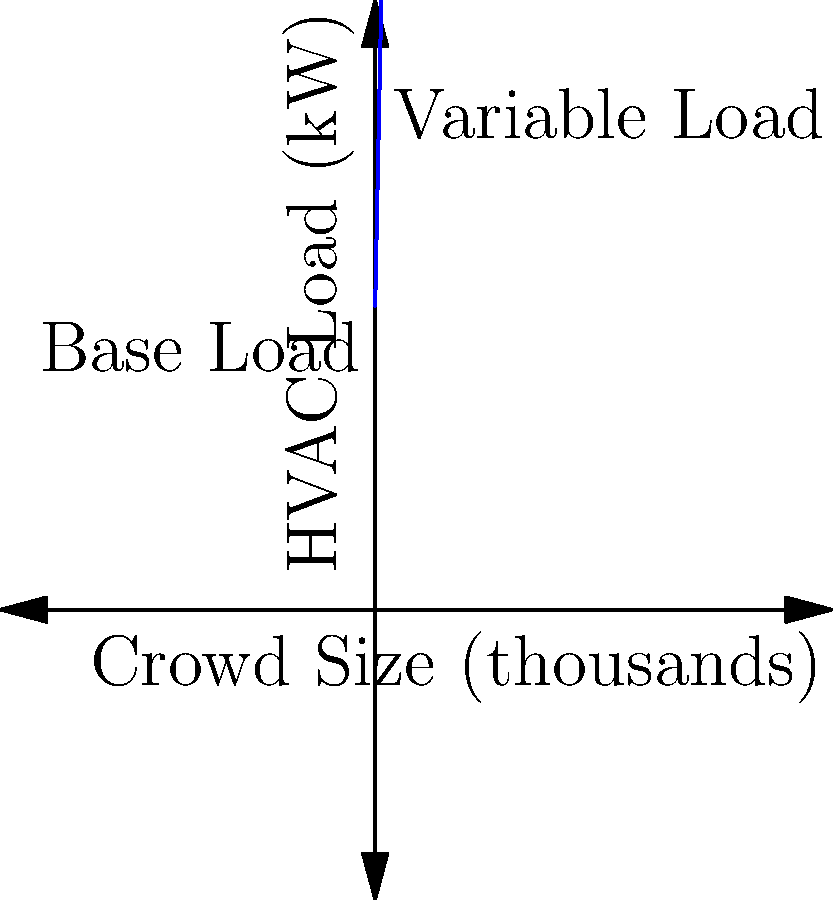As a basketball coach, you're consulted on the HVAC system design for a new arena. The graph shows the relationship between crowd size and HVAC load. If the arena capacity is 20,000 and the base load is 500 kW, what's the total HVAC load in kilowatts when the arena is at full capacity? To solve this problem, let's break it down step-by-step:

1. Understand the graph:
   - The y-intercept (500 kW) represents the base load.
   - The slope of the line represents the increase in HVAC load per thousand spectators.

2. Calculate the slope:
   - From the graph, we can see that for every 10,000 spectators, the load increases by about 500 kW.
   - Slope = 500 kW / 10,000 = 0.05 kW per spectator

3. Set up the equation:
   - Total Load = Base Load + (Spectators × Load per Spectator)
   - Let x be the number of spectators in thousands
   - Equation: $y = 500 + 50x$

4. Plug in the full capacity:
   - Full capacity is 20,000 spectators, so x = 20
   - $y = 500 + 50(20)$
   - $y = 500 + 1000 = 1500$

Therefore, the total HVAC load when the arena is at full capacity (20,000 spectators) is 1500 kW.
Answer: 1500 kW 